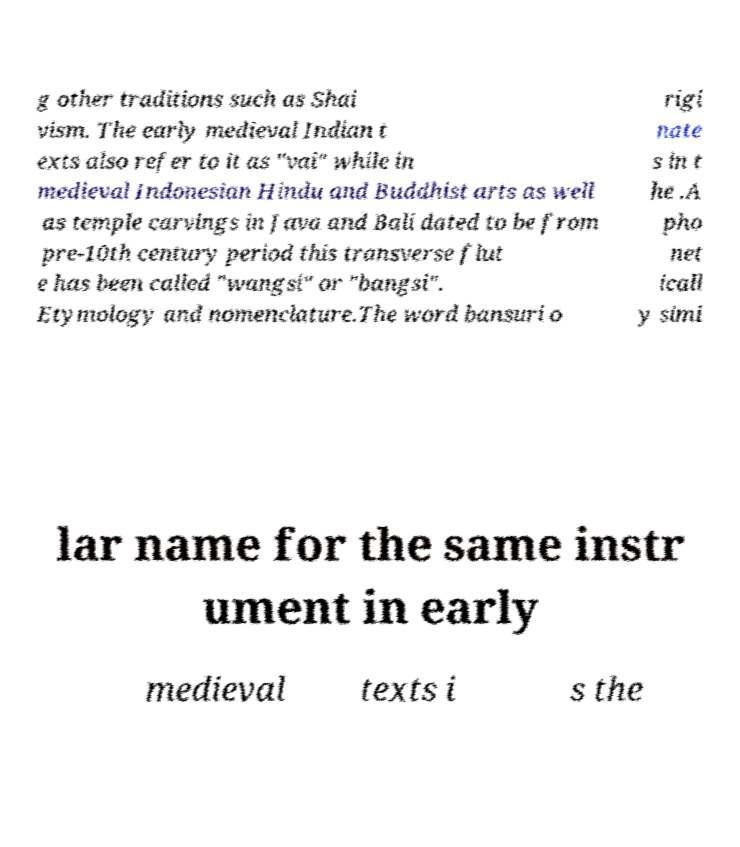Can you accurately transcribe the text from the provided image for me? g other traditions such as Shai vism. The early medieval Indian t exts also refer to it as "vai" while in medieval Indonesian Hindu and Buddhist arts as well as temple carvings in Java and Bali dated to be from pre-10th century period this transverse flut e has been called "wangsi" or "bangsi". Etymology and nomenclature.The word bansuri o rigi nate s in t he .A pho net icall y simi lar name for the same instr ument in early medieval texts i s the 